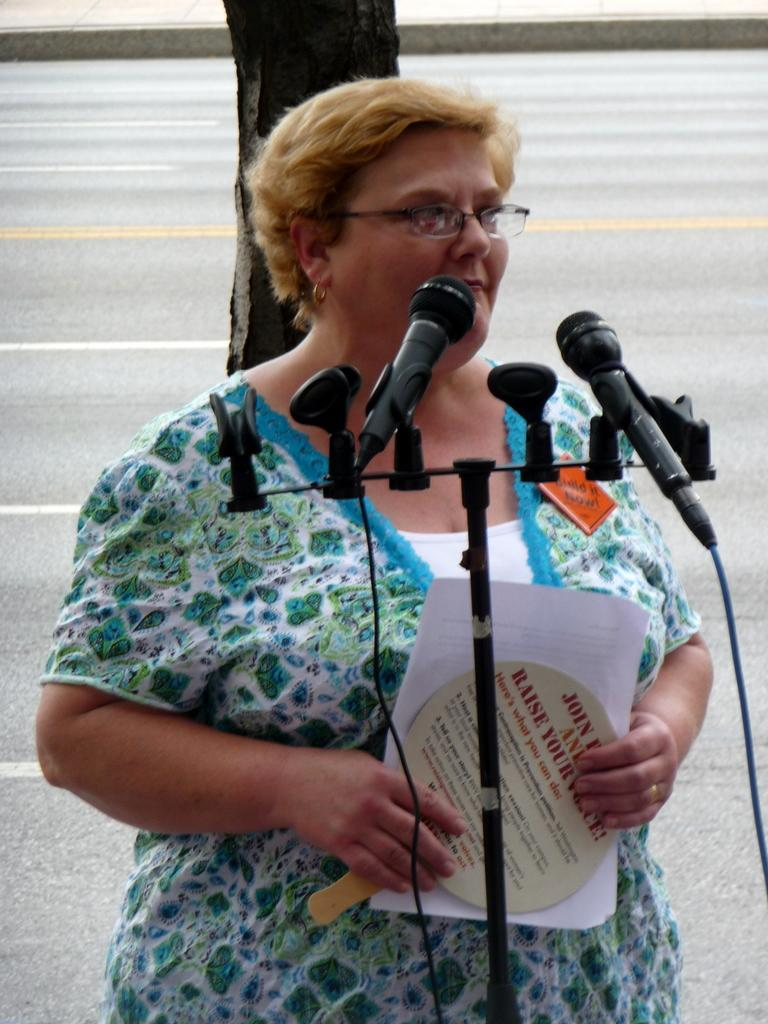Who is the main subject in the image? There is a woman in the image. What is the woman holding in her hand? The woman is holding a paper in her hand. What object is the woman standing in front of? The woman is standing in front of a microphone (mic). How many oranges can be seen in the image? There are no oranges present in the image. 